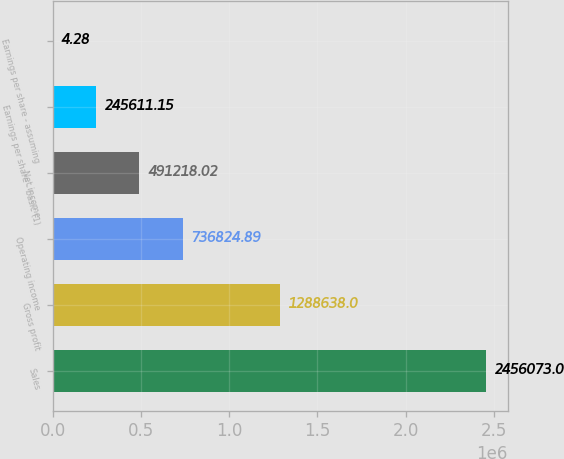Convert chart to OTSL. <chart><loc_0><loc_0><loc_500><loc_500><bar_chart><fcel>Sales<fcel>Gross profit<fcel>Operating income<fcel>Net income<fcel>Earnings per share - basic (1)<fcel>Earnings per share - assuming<nl><fcel>2.45607e+06<fcel>1.28864e+06<fcel>736825<fcel>491218<fcel>245611<fcel>4.28<nl></chart> 